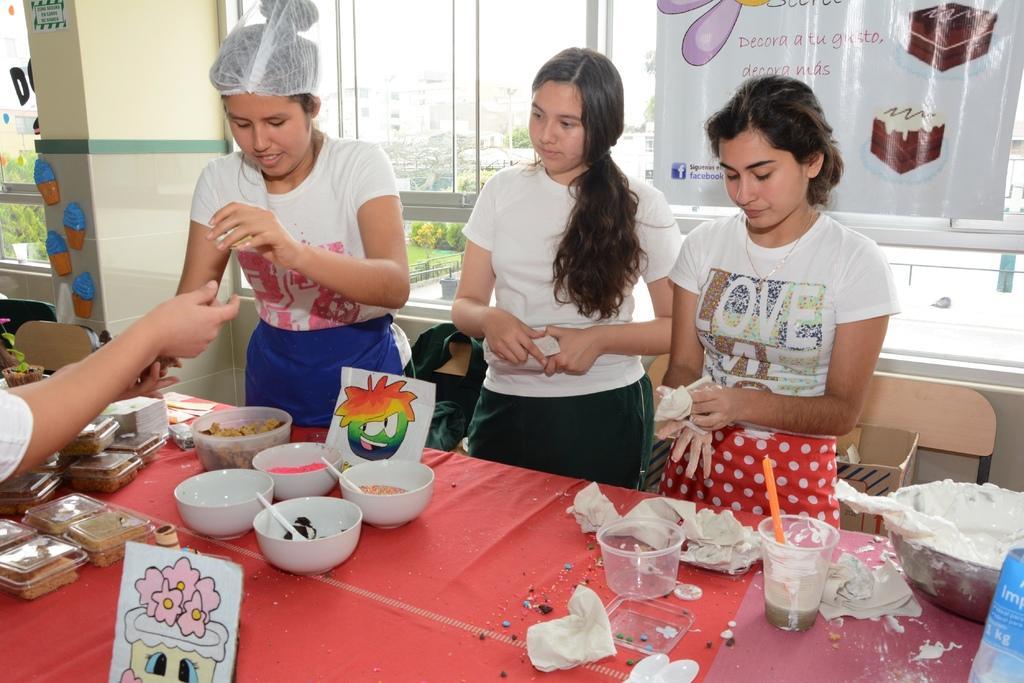Can you describe this image briefly? In this image we can see women standing on the floor and a table is placed in front of them. On the table we can see serving bowls with food in them, disposable tumblers, food packed in the cartons and decor plants. In the background there are advertising and decor on the wall, chairs, cardboard carton on the chair, buildings, trees and sky. 